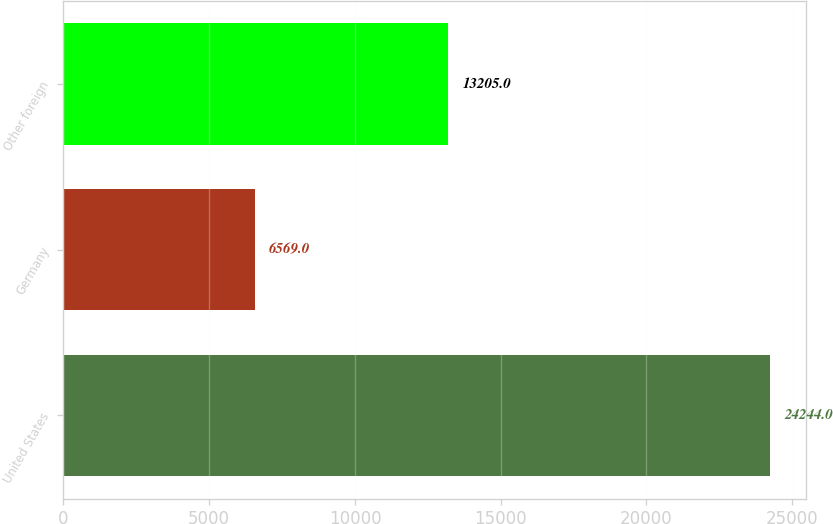Convert chart to OTSL. <chart><loc_0><loc_0><loc_500><loc_500><bar_chart><fcel>United States<fcel>Germany<fcel>Other foreign<nl><fcel>24244<fcel>6569<fcel>13205<nl></chart> 